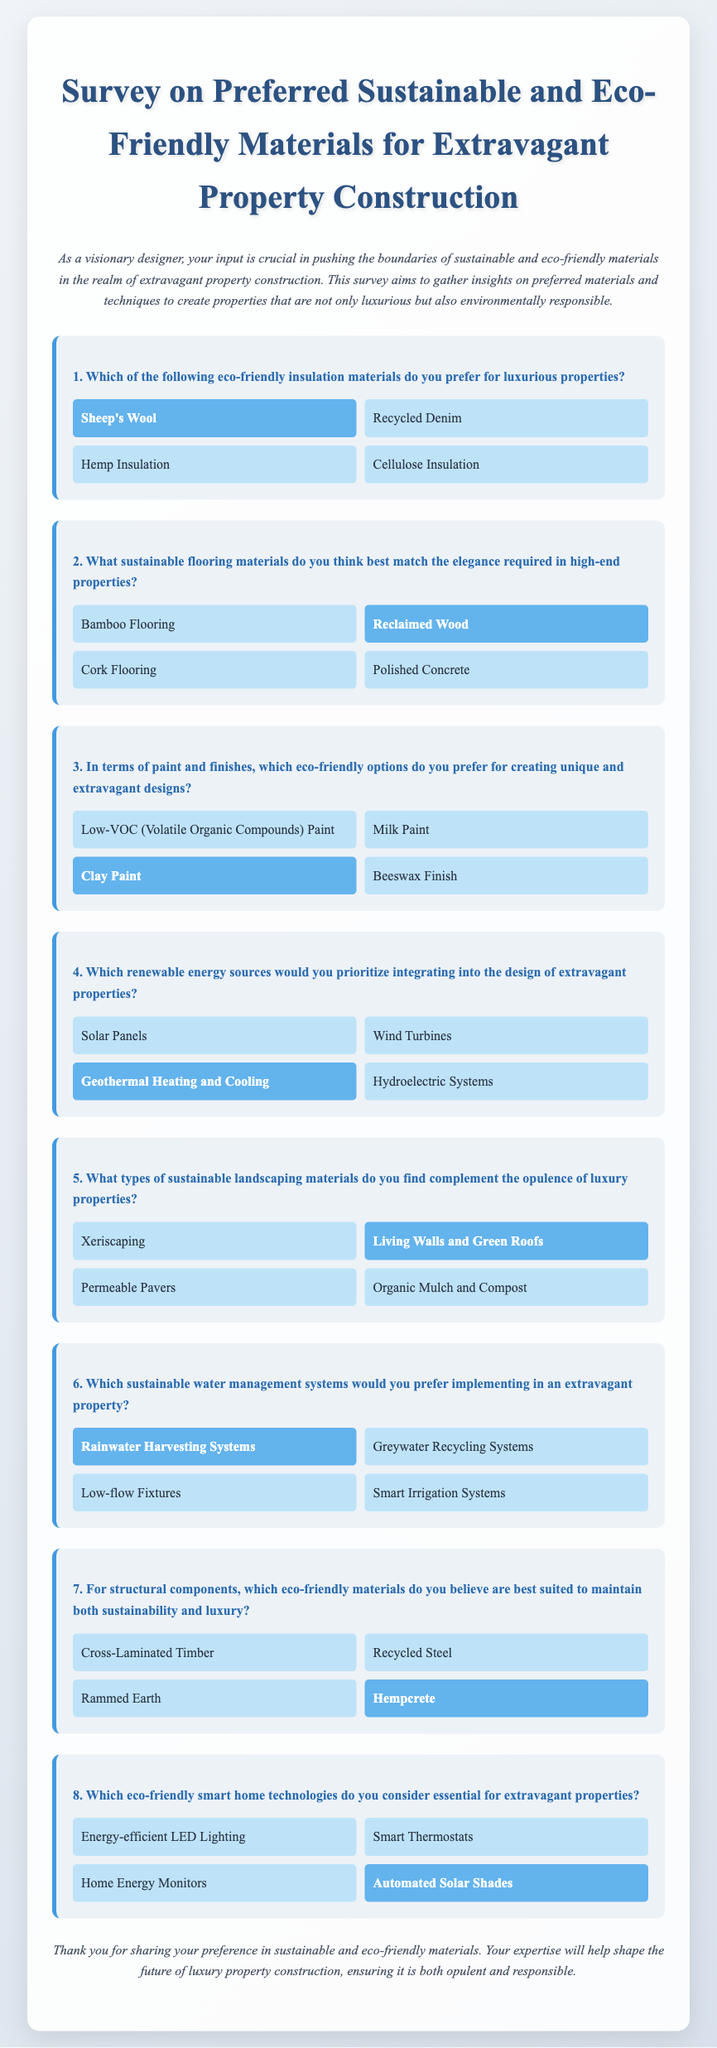What eco-friendly insulation material was preferred? The preferred eco-friendly insulation material is highlighted as Sheep's Wool in the document.
Answer: Sheep's Wool Which flooring material was selected for high-end properties? The selected flooring material, which indicates preference, is labeled as Reclaimed Wood in the document.
Answer: Reclaimed Wood What eco-friendly paint option was chosen for designs? The document specifies that Clay Paint is the eco-friendly paint option preferred for unique designs.
Answer: Clay Paint Which renewable energy source is prioritized in the design? The document states that Geothermal Heating and Cooling is the prioritized renewable energy source.
Answer: Geothermal Heating and Cooling What type of sustainable landscaping material was indicated as preferred? The chosen sustainable landscaping material, as indicated in the document, is Living Walls and Green Roofs.
Answer: Living Walls and Green Roofs Which water management system was selected for implementation? The selected sustainable water management system noted in the document is Rainwater Harvesting Systems.
Answer: Rainwater Harvesting Systems What eco-friendly structural material was identified? The document implies that Hempcrete is the eco-friendly structural material that is believed to maintain sustainability and luxury.
Answer: Hempcrete Which smart home technology is considered essential? The document highlights Automated Solar Shades as the essential eco-friendly smart home technology.
Answer: Automated Solar Shades What is the overall purpose of the survey? The survey aims to gather insights on sustainable and eco-friendly materials for extravagant property construction.
Answer: Gather insights on sustainable materials 